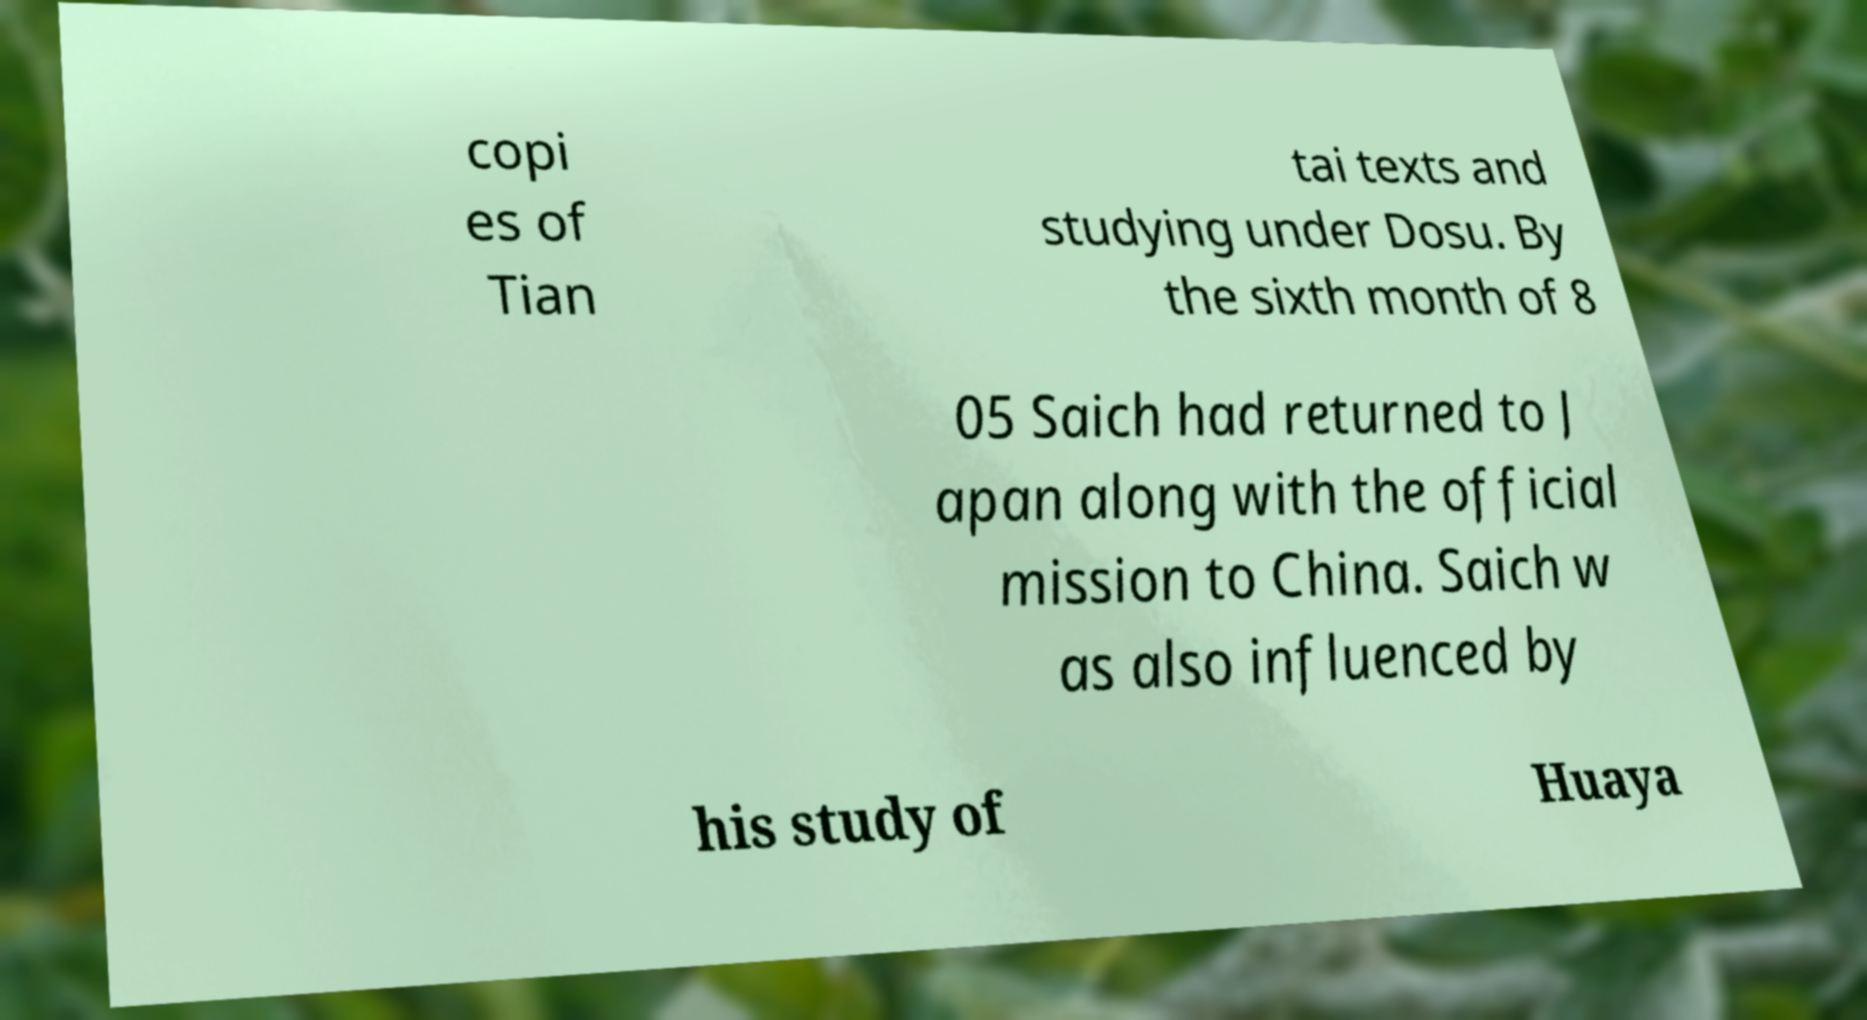Could you assist in decoding the text presented in this image and type it out clearly? copi es of Tian tai texts and studying under Dosu. By the sixth month of 8 05 Saich had returned to J apan along with the official mission to China. Saich w as also influenced by his study of Huaya 